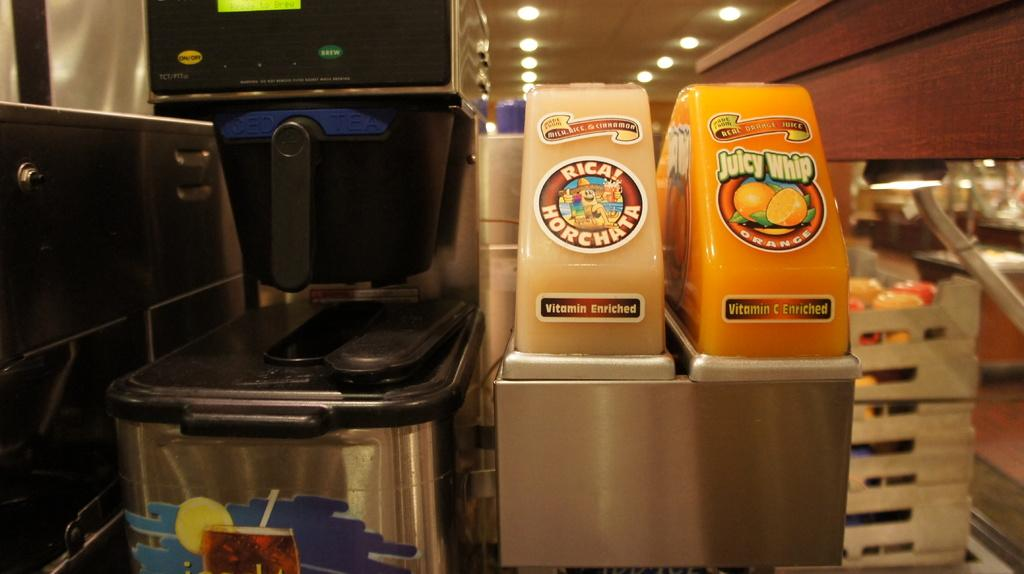<image>
Share a concise interpretation of the image provided. One of the two beverage dispensers is for Juicy Whip orange juice 